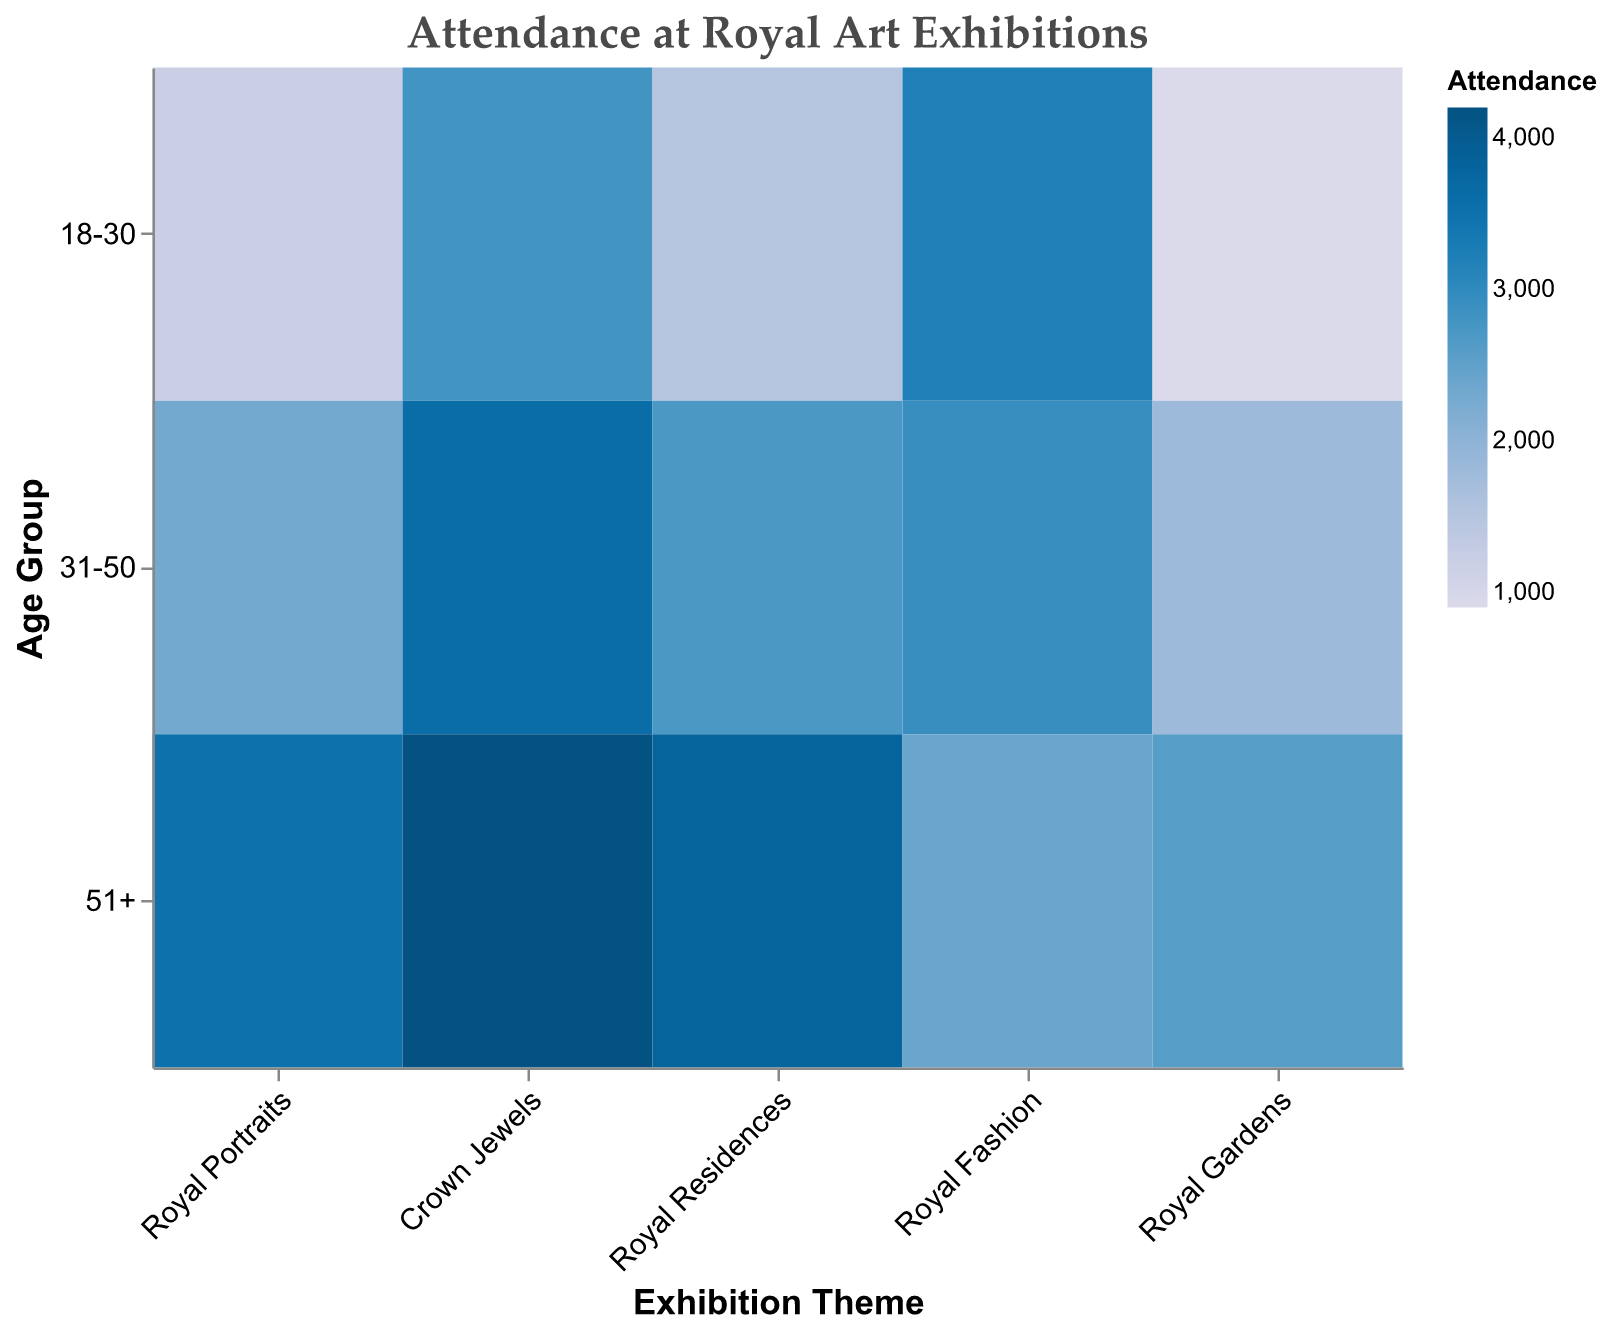What is the title of the figure? The title is usually found at the top of the figure and describes the content. Here, it's positioned centrally and is written in a larger font size.
Answer: Attendance at Royal Art Exhibitions Which exhibition theme has the highest attendance for the 18-30 age group? By looking at the color blocks for the 18-30 age group across different themes, the darkest color represents the highest attendance. The darkest color for this age group is for Royal Fashion.
Answer: Royal Fashion Which age group shows the least interest in Royal Gardens exhibitions? The mosaic plot's shading indicates attendance, with lighter colors representing lower attendance. The lightest shade in the Royal Gardens section is for the 18-30 age group.
Answer: 18-30 How does attendance for Crown Jewels compare between the 18-30 and 51+ age groups? Compare the color shades for Crown Jewels between the specified age groups. The 51+ group has a much darker shade than the 18-30 group, indicating higher attendance.
Answer: 51+ has higher attendance What is the total attendance for the Royal Residences exhibition? Sum the attendance figures for all age groups under Royal Residences: 1500 (18-30) + 2700 (31-50) + 3800 (51+). The total attendance is 8,000.
Answer: 8000 Which age group has the highest attendance across all exhibition themes? Compare the darkest colors horizontally across all themes in the mosaic plot. The 51+ age group consistently shows the darkest shades, indicating the highest attendance overall.
Answer: 51+ Between Royal Portraits and Royal Fashion, which theme attracts more visitors in the 31-50 age group? Compare the colors for the 31-50 age group within these two themes. Royal Portraits has 2,300 visitors (lighter color), while Royal Fashion has 2,900 (darker color).
Answer: Royal Fashion How does the popularity of Royal Gardens compare to the overall attendance distribution of other themes for the age group 31-50? The colors for the 31-50 age group in Royal Gardens should be compared to the colors in other themes. Royal Gardens is significantly lighter, meaning lower attendance.
Answer: Royal Gardens is less popular Which exhibition theme shows the greatest variation in attendance between age groups? Assess the range of color intensities within each theme. The Royal Fashion theme has a significant variation from dark (18-30) to lighter shades (51+).
Answer: Royal Fashion In which age group is the difference most pronounced between Crown Jewels and Royal Gardens attendance? For each age group, compare the color difference between Crown Jewels and Royal Gardens. The 51+ group has the highest difference, with Crown Jewels being much darker.
Answer: 51+ 